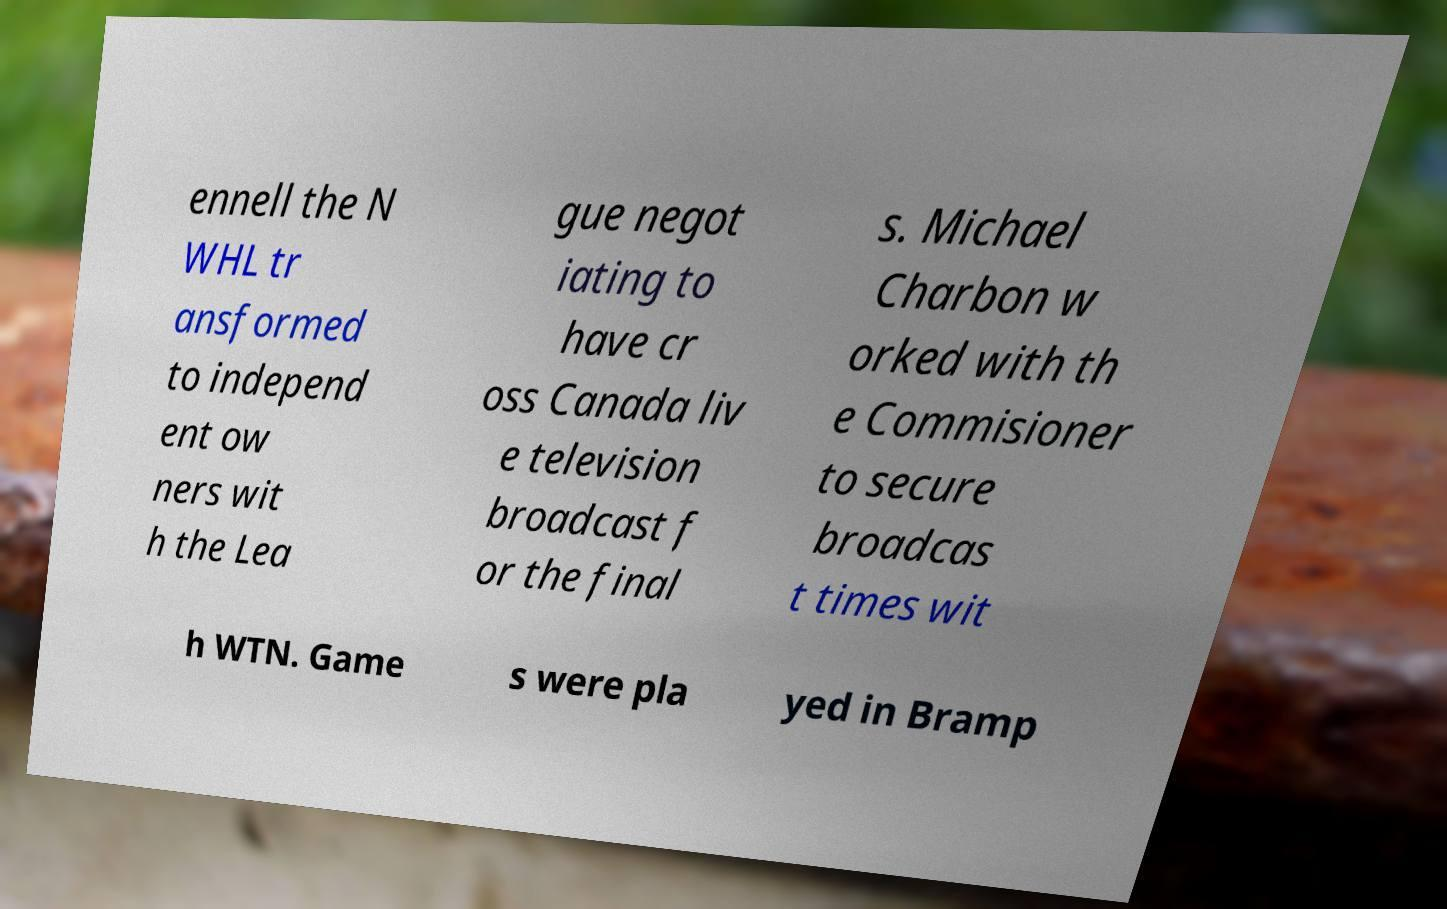What messages or text are displayed in this image? I need them in a readable, typed format. ennell the N WHL tr ansformed to independ ent ow ners wit h the Lea gue negot iating to have cr oss Canada liv e television broadcast f or the final s. Michael Charbon w orked with th e Commisioner to secure broadcas t times wit h WTN. Game s were pla yed in Bramp 